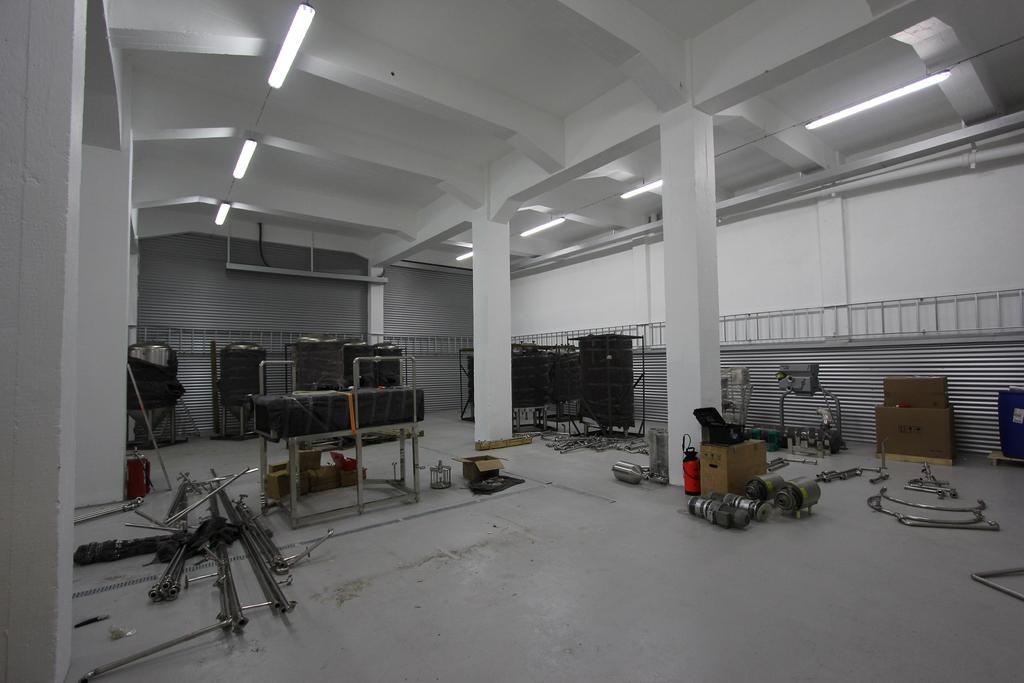Could you give a brief overview of what you see in this image? In this image I can see the floor, few metal rods on the floor, few metal objects, few tables and few cardboard boxes. I can see few pillars, few tanks, the ceiling, few lights to the ceiling and the wall. 